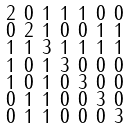Convert formula to latex. <formula><loc_0><loc_0><loc_500><loc_500>\begin{smallmatrix} 2 & 0 & 1 & 1 & 1 & 0 & 0 \\ 0 & 2 & 1 & 0 & 0 & 1 & 1 \\ 1 & 1 & 3 & 1 & 1 & 1 & 1 \\ 1 & 0 & 1 & 3 & 0 & 0 & 0 \\ 1 & 0 & 1 & 0 & 3 & 0 & 0 \\ 0 & 1 & 1 & 0 & 0 & 3 & 0 \\ 0 & 1 & 1 & 0 & 0 & 0 & 3 \end{smallmatrix}</formula> 